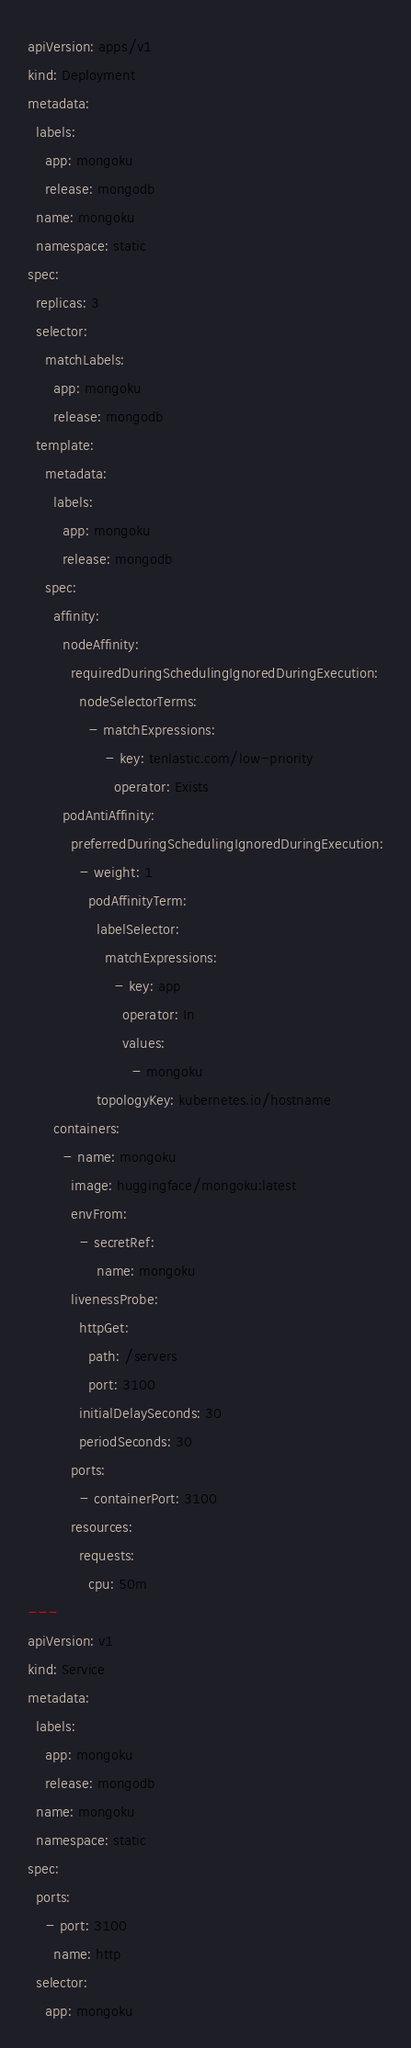Convert code to text. <code><loc_0><loc_0><loc_500><loc_500><_YAML_>apiVersion: apps/v1
kind: Deployment
metadata:
  labels:
    app: mongoku
    release: mongodb
  name: mongoku
  namespace: static
spec:
  replicas: 3
  selector:
    matchLabels:
      app: mongoku
      release: mongodb
  template:
    metadata:
      labels:
        app: mongoku
        release: mongodb
    spec:
      affinity:
        nodeAffinity:
          requiredDuringSchedulingIgnoredDuringExecution:
            nodeSelectorTerms:
              - matchExpressions:
                  - key: tenlastic.com/low-priority
                    operator: Exists
        podAntiAffinity:
          preferredDuringSchedulingIgnoredDuringExecution:
            - weight: 1
              podAffinityTerm:
                labelSelector:
                  matchExpressions:
                    - key: app
                      operator: In
                      values:
                        - mongoku
                topologyKey: kubernetes.io/hostname
      containers:
        - name: mongoku
          image: huggingface/mongoku:latest
          envFrom:
            - secretRef:
                name: mongoku
          livenessProbe:
            httpGet:
              path: /servers
              port: 3100
            initialDelaySeconds: 30
            periodSeconds: 30
          ports:
            - containerPort: 3100
          resources:
            requests:
              cpu: 50m
---
apiVersion: v1
kind: Service
metadata:
  labels:
    app: mongoku
    release: mongodb
  name: mongoku
  namespace: static
spec:
  ports:
    - port: 3100
      name: http
  selector:
    app: mongoku
</code> 